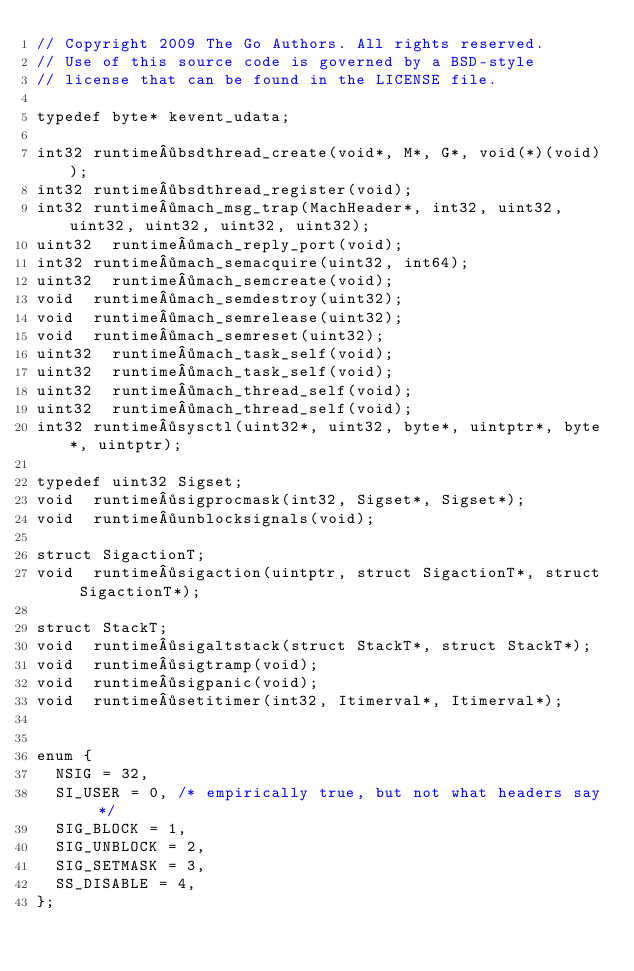Convert code to text. <code><loc_0><loc_0><loc_500><loc_500><_C_>// Copyright 2009 The Go Authors. All rights reserved.
// Use of this source code is governed by a BSD-style
// license that can be found in the LICENSE file.

typedef byte* kevent_udata;

int32	runtime·bsdthread_create(void*, M*, G*, void(*)(void));
int32	runtime·bsdthread_register(void);
int32	runtime·mach_msg_trap(MachHeader*, int32, uint32, uint32, uint32, uint32, uint32);
uint32	runtime·mach_reply_port(void);
int32	runtime·mach_semacquire(uint32, int64);
uint32	runtime·mach_semcreate(void);
void	runtime·mach_semdestroy(uint32);
void	runtime·mach_semrelease(uint32);
void	runtime·mach_semreset(uint32);
uint32	runtime·mach_task_self(void);
uint32	runtime·mach_task_self(void);
uint32	runtime·mach_thread_self(void);
uint32	runtime·mach_thread_self(void);
int32	runtime·sysctl(uint32*, uint32, byte*, uintptr*, byte*, uintptr);

typedef uint32 Sigset;
void	runtime·sigprocmask(int32, Sigset*, Sigset*);
void	runtime·unblocksignals(void);

struct SigactionT;
void	runtime·sigaction(uintptr, struct SigactionT*, struct SigactionT*);

struct StackT;
void	runtime·sigaltstack(struct StackT*, struct StackT*);
void	runtime·sigtramp(void);
void	runtime·sigpanic(void);
void	runtime·setitimer(int32, Itimerval*, Itimerval*);


enum {
	NSIG = 32,
	SI_USER = 0, /* empirically true, but not what headers say */
	SIG_BLOCK = 1,
	SIG_UNBLOCK = 2,
	SIG_SETMASK = 3,
	SS_DISABLE = 4,
};
</code> 